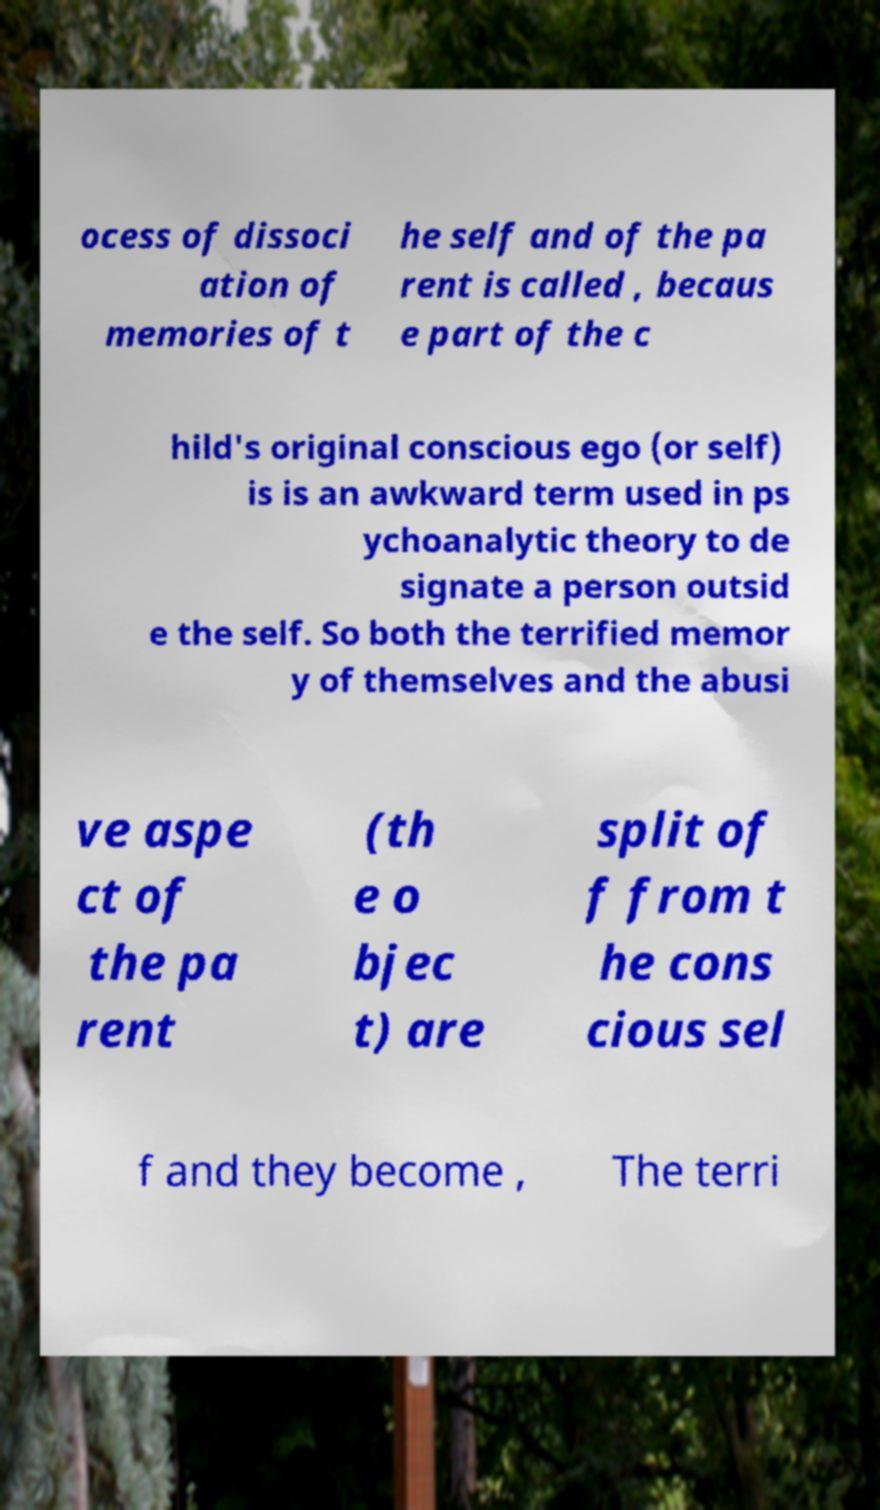Could you assist in decoding the text presented in this image and type it out clearly? ocess of dissoci ation of memories of t he self and of the pa rent is called , becaus e part of the c hild's original conscious ego (or self) is is an awkward term used in ps ychoanalytic theory to de signate a person outsid e the self. So both the terrified memor y of themselves and the abusi ve aspe ct of the pa rent (th e o bjec t) are split of f from t he cons cious sel f and they become , The terri 